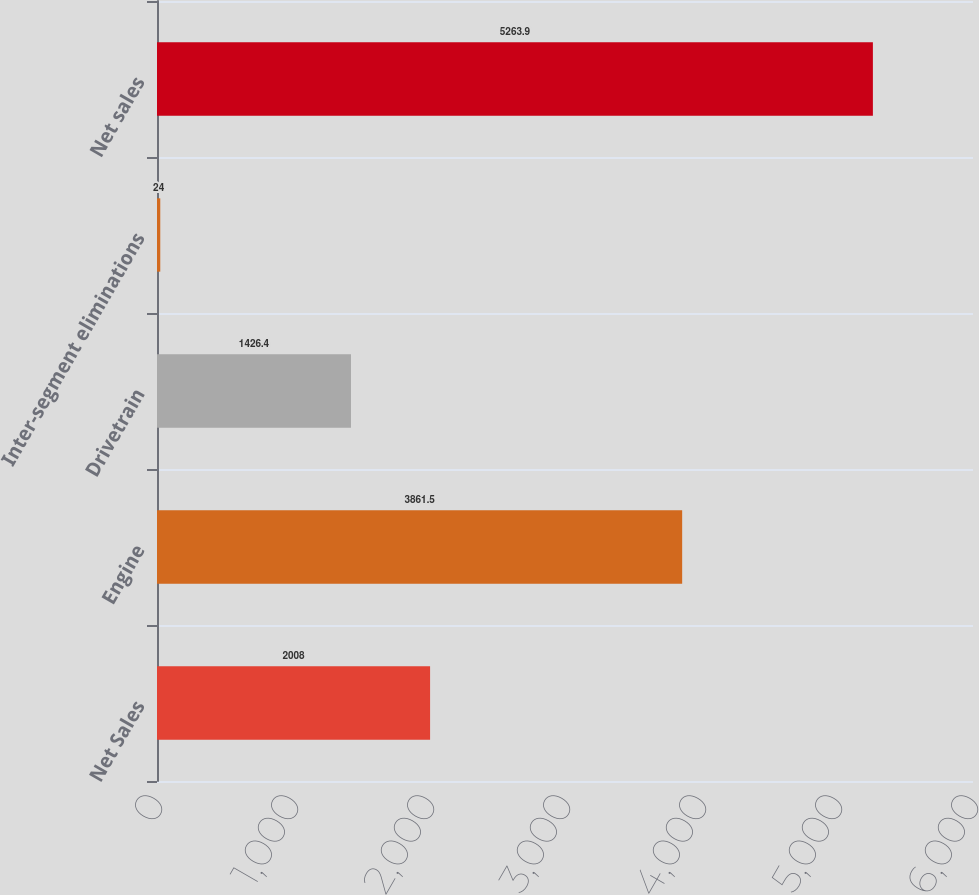Convert chart to OTSL. <chart><loc_0><loc_0><loc_500><loc_500><bar_chart><fcel>Net Sales<fcel>Engine<fcel>Drivetrain<fcel>Inter-segment eliminations<fcel>Net sales<nl><fcel>2008<fcel>3861.5<fcel>1426.4<fcel>24<fcel>5263.9<nl></chart> 